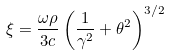Convert formula to latex. <formula><loc_0><loc_0><loc_500><loc_500>\xi = \frac { \omega \rho } { 3 c } \left ( \frac { 1 } { \gamma ^ { 2 } } + \theta ^ { 2 } \right ) ^ { 3 / 2 }</formula> 